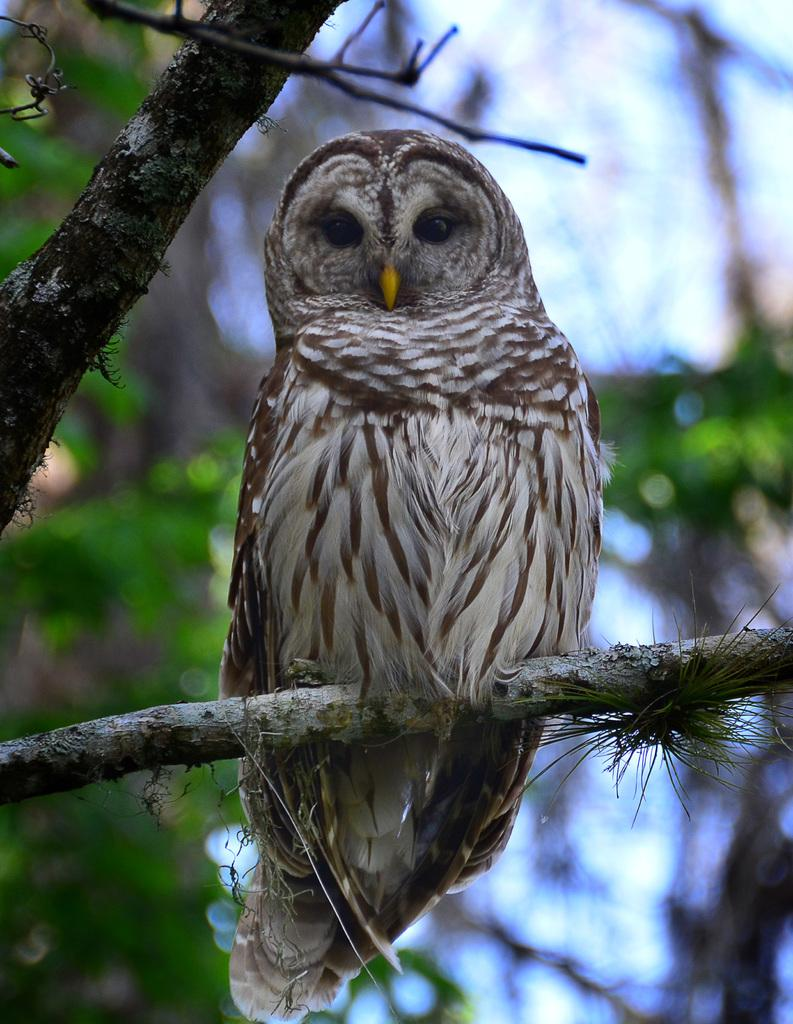What animal is present in the image? There is an owl in the image. Where is the owl located? The owl is on a branch. Are there any other branches visible in the image? Yes, there is another branch visible in the image. How would you describe the background of the image? The background of the image is blurred. What type of cable can be seen hanging from the branch in the image? There is no cable present in the image; it only features an owl on a branch and another branch in the background. 